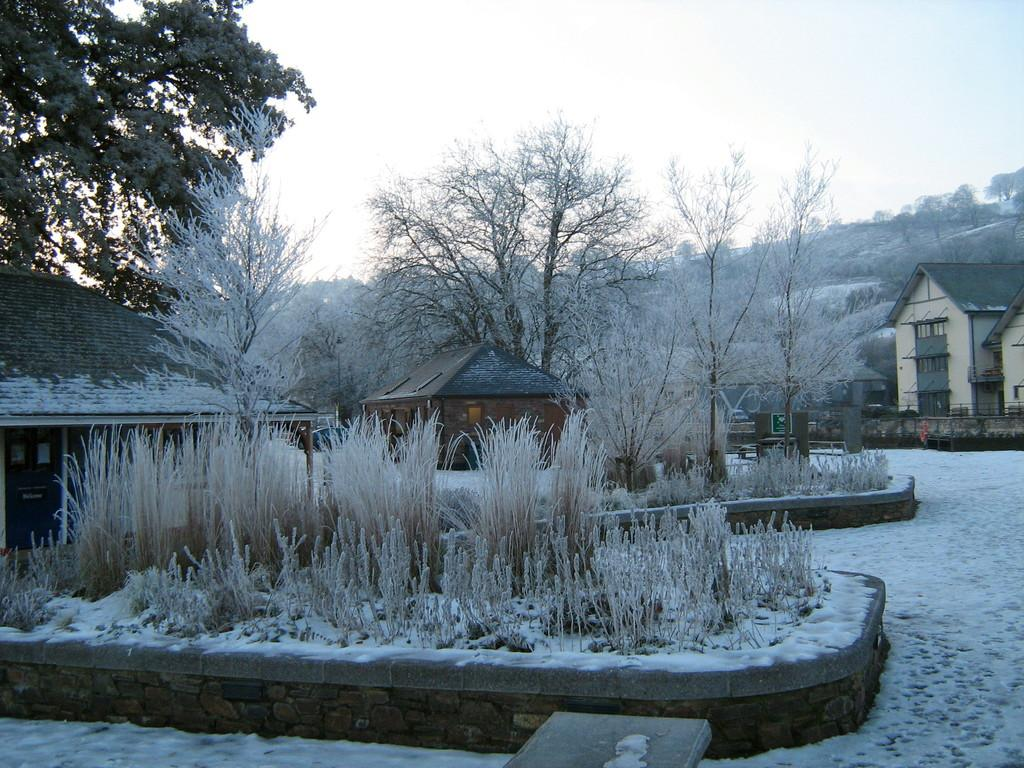What type of structures can be seen in the image? There are houses in the image. What is covering the ground in the image? There is snow on the ground in the image. What type of vegetation is visible in the image? There are trees and plants visible in the image. What is visible at the top of the image? The sky is visible at the top of the image. Where is the distribution center located in the image? There is no distribution center present in the image. What type of patch is visible on the trees in the image? There are no patches visible on the trees in the image; only snow, houses, trees, plants, and the sky are present. 